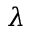<formula> <loc_0><loc_0><loc_500><loc_500>\lambda</formula> 